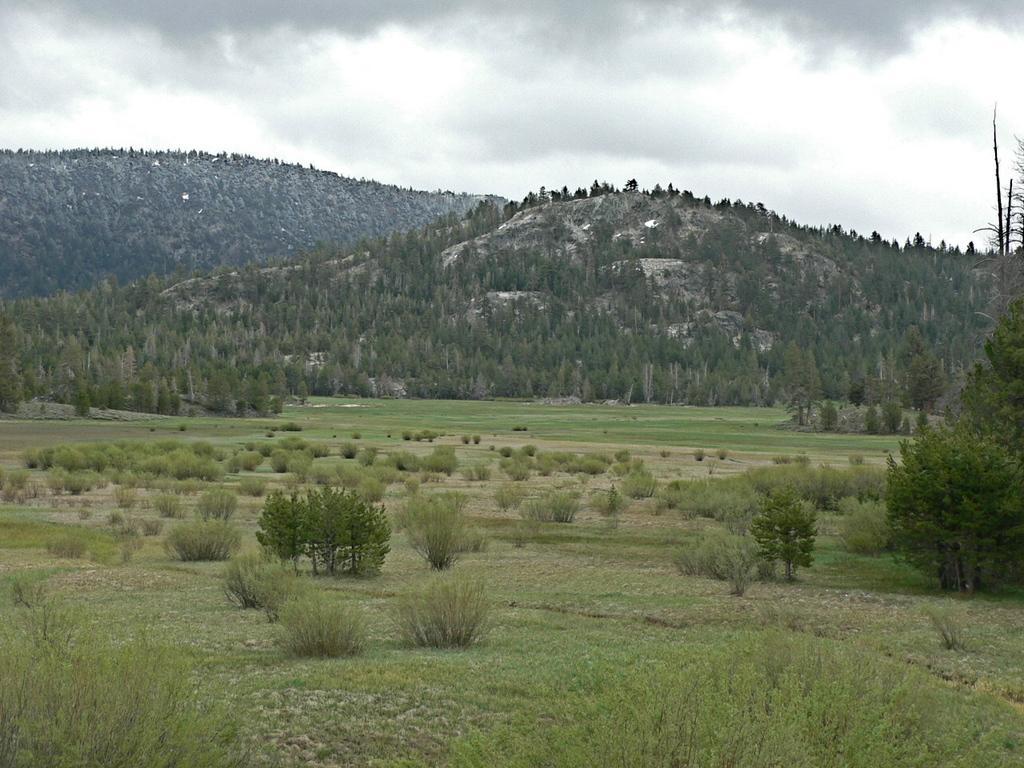In one or two sentences, can you explain what this image depicts? In this image I can see the ground, some grass on the ground and few trees which are green in color on the ground. In the background I can see few mountains, few trees on the mountains and the sky. 